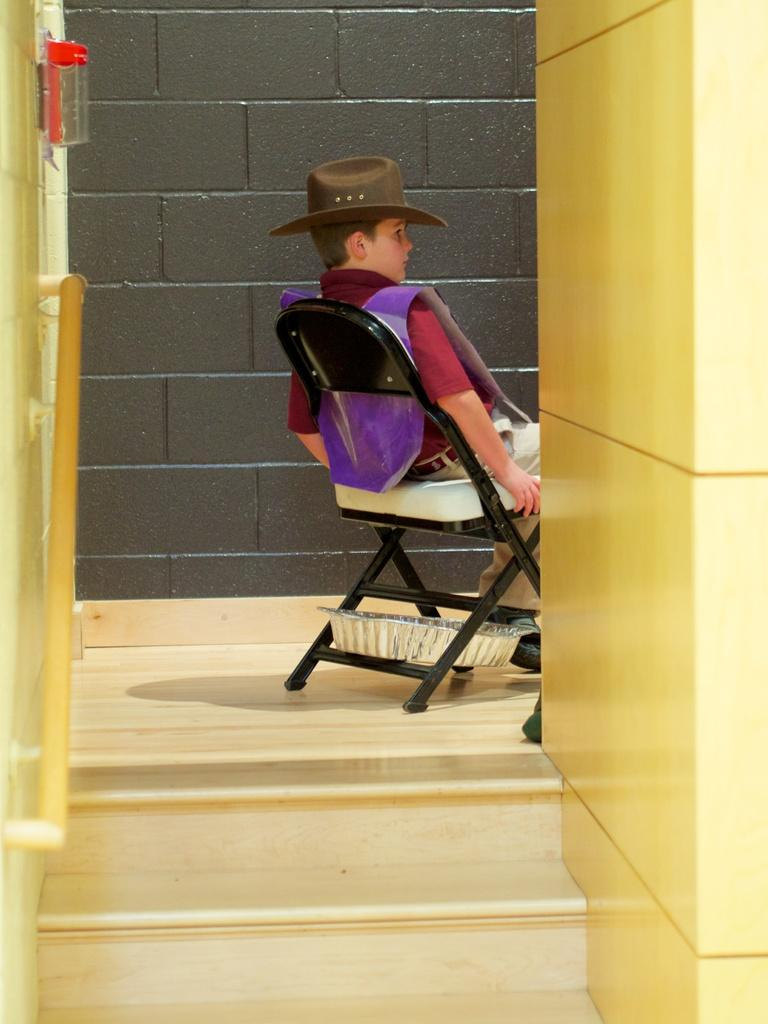Who is the main subject in the image? There is a boy in the image. What is the boy doing in the image? The boy is sitting on a chair. How many stairs are visible in the image? There are 2 stairs in the image. What type of wall can be seen in the background of the image? There is a wall made of bricks in the background of the image. What type of noise can be heard coming from the cemetery in the image? There is no cemetery present in the image, so it's not possible to determine what, if any, noise might be heard. 